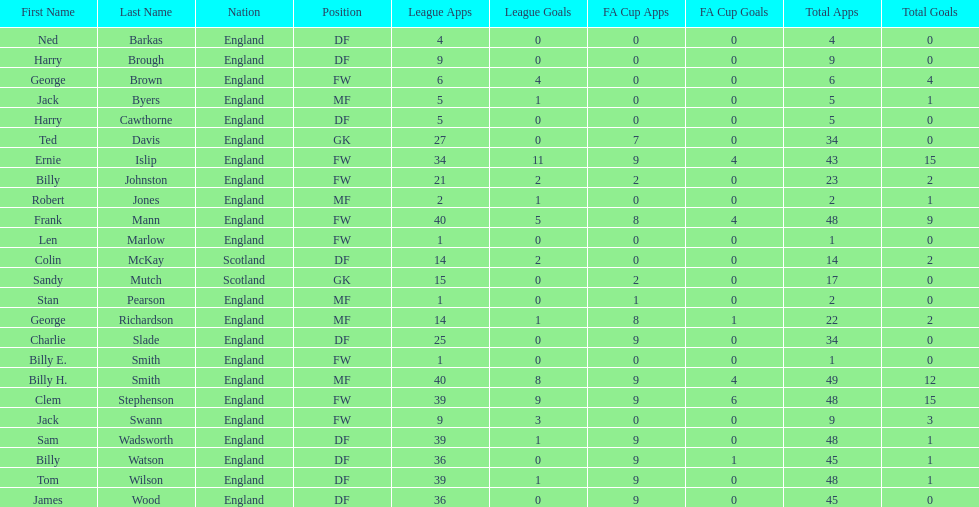What is the average number of scotland's total apps? 15.5. Could you parse the entire table as a dict? {'header': ['First Name', 'Last Name', 'Nation', 'Position', 'League Apps', 'League Goals', 'FA Cup Apps', 'FA Cup Goals', 'Total Apps', 'Total Goals'], 'rows': [['Ned', 'Barkas', 'England', 'DF', '4', '0', '0', '0', '4', '0'], ['Harry', 'Brough', 'England', 'DF', '9', '0', '0', '0', '9', '0'], ['George', 'Brown', 'England', 'FW', '6', '4', '0', '0', '6', '4'], ['Jack', 'Byers', 'England', 'MF', '5', '1', '0', '0', '5', '1'], ['Harry', 'Cawthorne', 'England', 'DF', '5', '0', '0', '0', '5', '0'], ['Ted', 'Davis', 'England', 'GK', '27', '0', '7', '0', '34', '0'], ['Ernie', 'Islip', 'England', 'FW', '34', '11', '9', '4', '43', '15'], ['Billy', 'Johnston', 'England', 'FW', '21', '2', '2', '0', '23', '2'], ['Robert', 'Jones', 'England', 'MF', '2', '1', '0', '0', '2', '1'], ['Frank', 'Mann', 'England', 'FW', '40', '5', '8', '4', '48', '9'], ['Len', 'Marlow', 'England', 'FW', '1', '0', '0', '0', '1', '0'], ['Colin', 'McKay', 'Scotland', 'DF', '14', '2', '0', '0', '14', '2'], ['Sandy', 'Mutch', 'Scotland', 'GK', '15', '0', '2', '0', '17', '0'], ['Stan', 'Pearson', 'England', 'MF', '1', '0', '1', '0', '2', '0'], ['George', 'Richardson', 'England', 'MF', '14', '1', '8', '1', '22', '2'], ['Charlie', 'Slade', 'England', 'DF', '25', '0', '9', '0', '34', '0'], ['Billy E.', 'Smith', 'England', 'FW', '1', '0', '0', '0', '1', '0'], ['Billy H.', 'Smith', 'England', 'MF', '40', '8', '9', '4', '49', '12'], ['Clem', 'Stephenson', 'England', 'FW', '39', '9', '9', '6', '48', '15'], ['Jack', 'Swann', 'England', 'FW', '9', '3', '0', '0', '9', '3'], ['Sam', 'Wadsworth', 'England', 'DF', '39', '1', '9', '0', '48', '1'], ['Billy', 'Watson', 'England', 'DF', '36', '0', '9', '1', '45', '1'], ['Tom', 'Wilson', 'England', 'DF', '39', '1', '9', '0', '48', '1'], ['James', 'Wood', 'England', 'DF', '36', '0', '9', '0', '45', '0']]} 